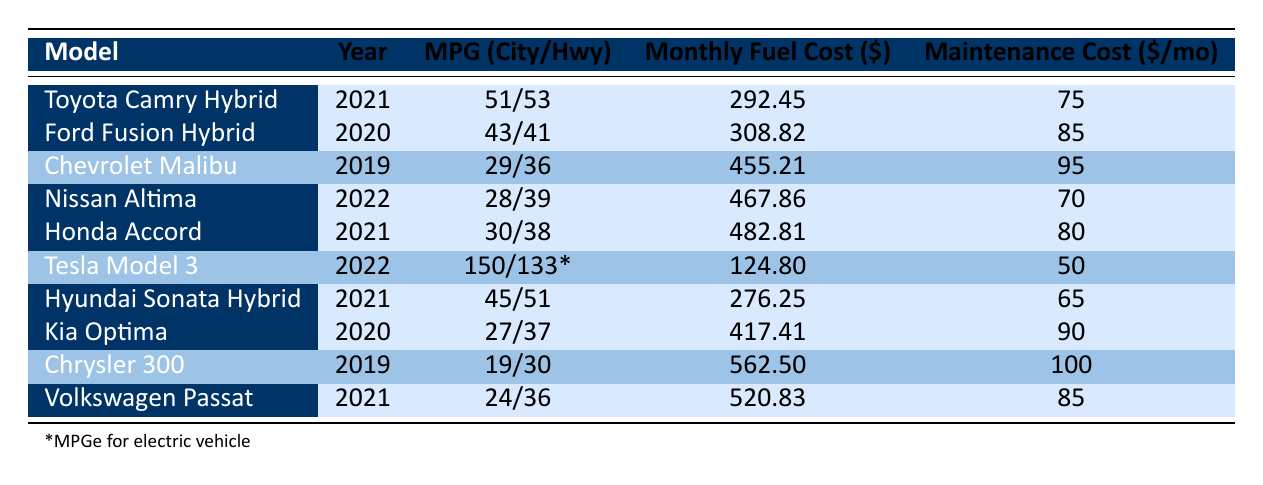What is the monthly fuel cost for the Toyota Camry Hybrid? From the table, we can see that the monthly fuel cost for the Toyota Camry Hybrid is listed under the "Monthly Fuel Cost" column for this model. It shows a value of 292.45.
Answer: 292.45 Which car has the highest maintenance cost per month? To find the car with the highest maintenance cost, we compare the values in the "Maintenance Cost" column. The highest value is for the Chrysler 300, which shows a maintenance cost of 100.
Answer: Chrysler 300 What is the average monthly fuel cost for all vehicles? To calculate the average monthly fuel cost, we sum the monthly fuel costs of all vehicles: (292.45 + 308.82 + 455.21 + 467.86 + 482.81 + 124.80 + 276.25 + 417.41 + 562.50 + 520.83) = 3090.43. There are 10 vehicles, so the average is 3090.43 / 10 = 309.04.
Answer: 309.04 Is the Honda Accord more fuel efficient in highway driving compared to the Nissan Altima? The fuel efficiency in highway driving can be determined by looking at the "MPG Highway" values for both cars. The Honda Accord has a highway MPG of 38, while the Nissan Altima has a highway MPG of 39. Since 38 is less than 39, the Honda Accord is not more fuel efficient than the Nissan Altima.
Answer: No How much more in monthly fuel cost does the Chevrolet Malibu incur compared to the Hyundai Sonata Hybrid? The monthly fuel costs for the Chevrolet Malibu and the Hyundai Sonata Hybrid are 455.21 and 276.25, respectively. To find the difference, we subtract the Sonata's cost from the Malibu's cost: 455.21 - 276.25 = 178.96.
Answer: 178.96 